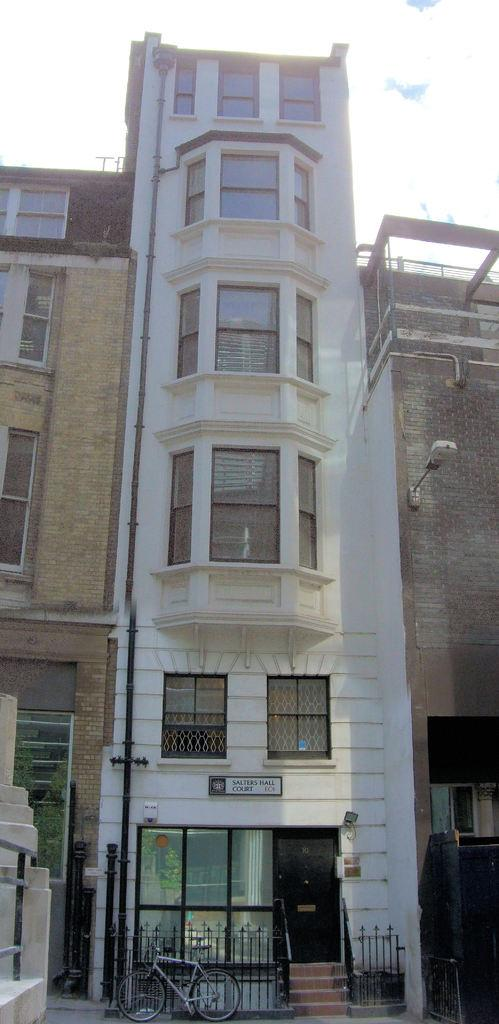What is the main structure in the center of the image? There is a building in the center of the image. What mode of transportation can be seen at the bottom of the image? A bicycle is visible at the bottom. What type of barrier is present at the bottom of the image? There is a fence at the bottom. Are there any architectural features that allow for vertical movement in the image? Yes, there are stairs in the image. What is visible in the background of the image? The sky is visible in the background. Where is the lettuce growing in the image? There is no lettuce present in the image. What type of birth is depicted in the image? There is no birth depicted in the image; it features a building, bicycle, fence, stairs, and sky. 